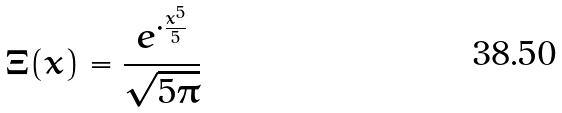<formula> <loc_0><loc_0><loc_500><loc_500>\Xi ( x ) = \frac { e ^ { \cdot \frac { x ^ { 5 } } { 5 } } } { \sqrt { 5 \pi } }</formula> 